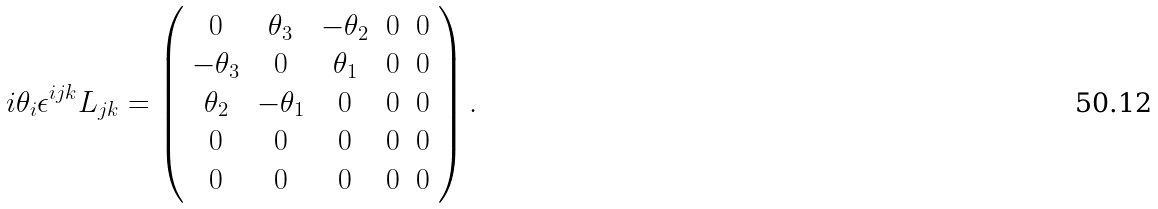<formula> <loc_0><loc_0><loc_500><loc_500>i \theta _ { i } \epsilon ^ { i j k } L _ { j k } = \left ( { \begin{array} { c c c c c } { 0 } & { \theta _ { 3 } } & { - \theta _ { 2 } } & { 0 } & { 0 } \\ { - \theta _ { 3 } } & { 0 } & { \theta _ { 1 } } & { 0 } & { 0 } \\ { \theta _ { 2 } } & { - \theta _ { 1 } } & { 0 } & { 0 } & { 0 } \\ { 0 } & { 0 } & { 0 } & { 0 } & { 0 } \\ { 0 } & { 0 } & { 0 } & { 0 } & { 0 } \end{array} } \right ) .</formula> 